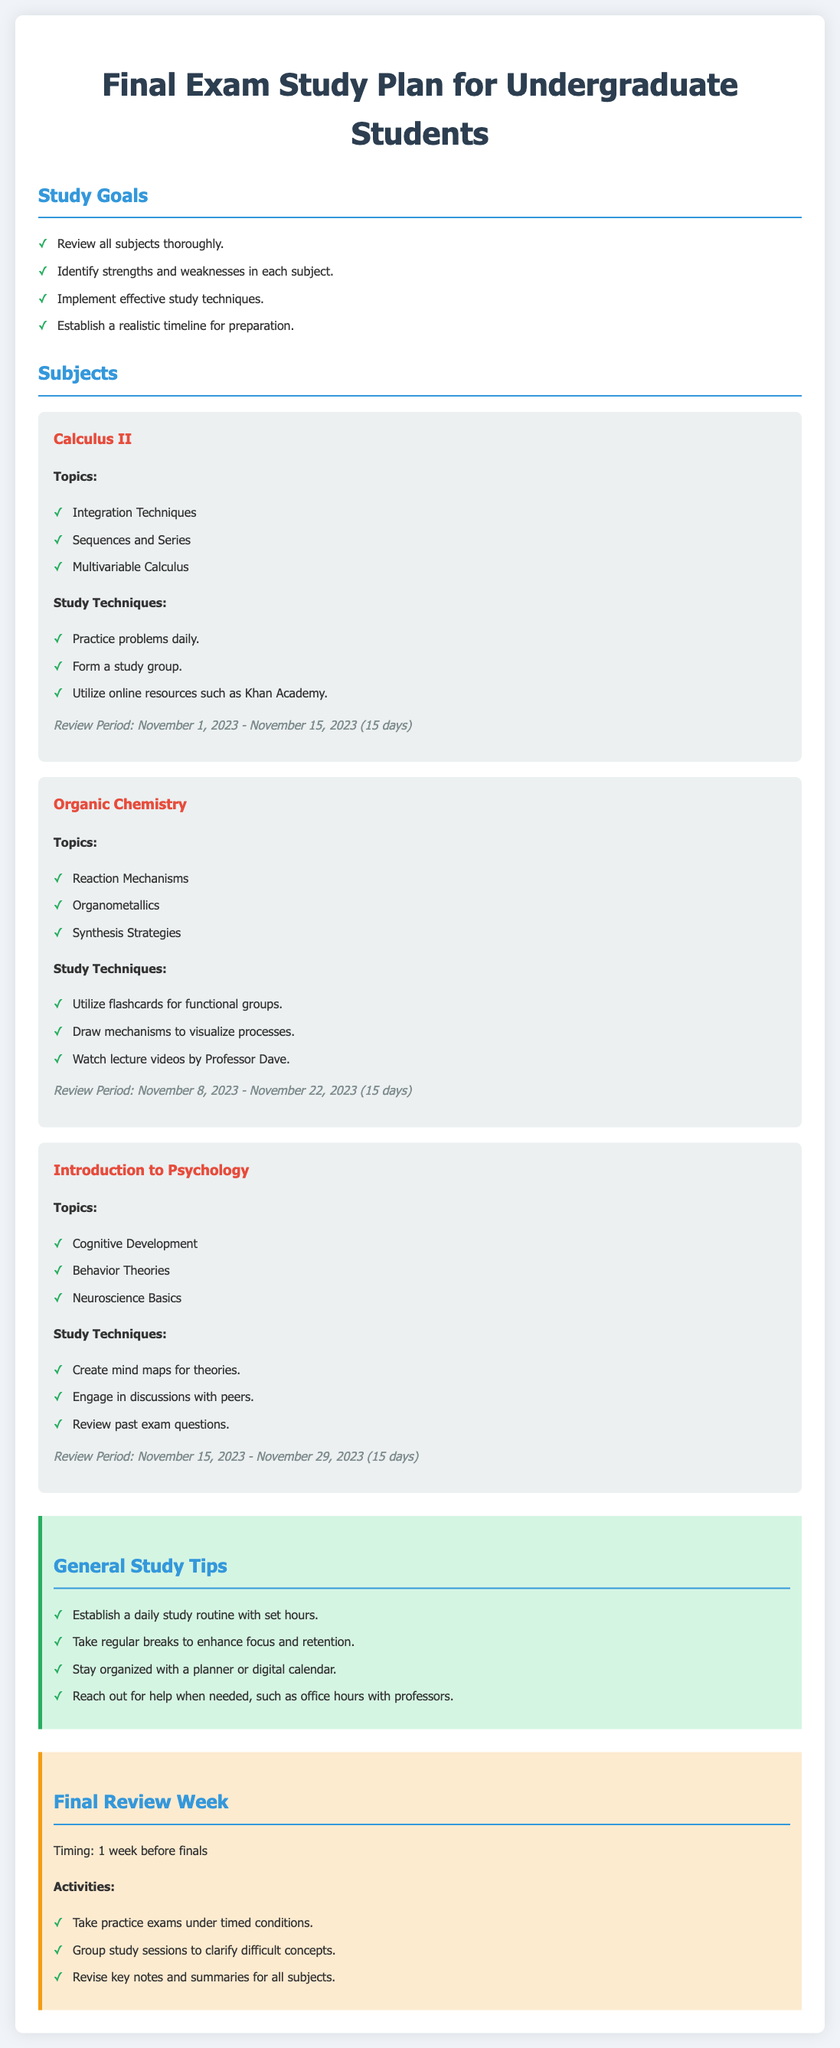What are the review period dates for Calculus II? The review period for Calculus II is specified as November 1, 2023 - November 15, 2023.
Answer: November 1, 2023 - November 15, 2023 What study technique is suggested for Organic Chemistry? One of the study techniques for Organic Chemistry is to draw mechanisms to visualize processes.
Answer: Draw mechanisms to visualize processes How long is the review period for Introduction to Psychology? The review period for Introduction to Psychology lasts for 15 days, as noted in the document.
Answer: 15 days What general study tip is given regarding breaks? It is advised to take regular breaks to enhance focus and retention.
Answer: Take regular breaks What is one activity suggested for the final review week? One activity suggested for the final review week is to take practice exams under timed conditions.
Answer: Take practice exams under timed conditions What subject covers "Multivariable Calculus"? The subject that covers "Multivariable Calculus" is Calculus II.
Answer: Calculus II When does the review period for Organic Chemistry begin? The review period for Organic Chemistry begins on November 8, 2023.
Answer: November 8, 2023 What is the focus of the general study tips section? The general study tips section focuses on enhancing study habits and organization.
Answer: Enhancing study habits and organization Which professor's lecture videos are recommended for Organic Chemistry? Professor Dave's lecture videos are recommended for Organic Chemistry.
Answer: Professor Dave 